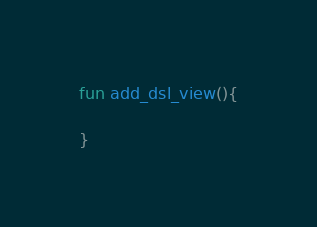<code> <loc_0><loc_0><loc_500><loc_500><_Kotlin_>

fun add_dsl_view(){

}</code> 